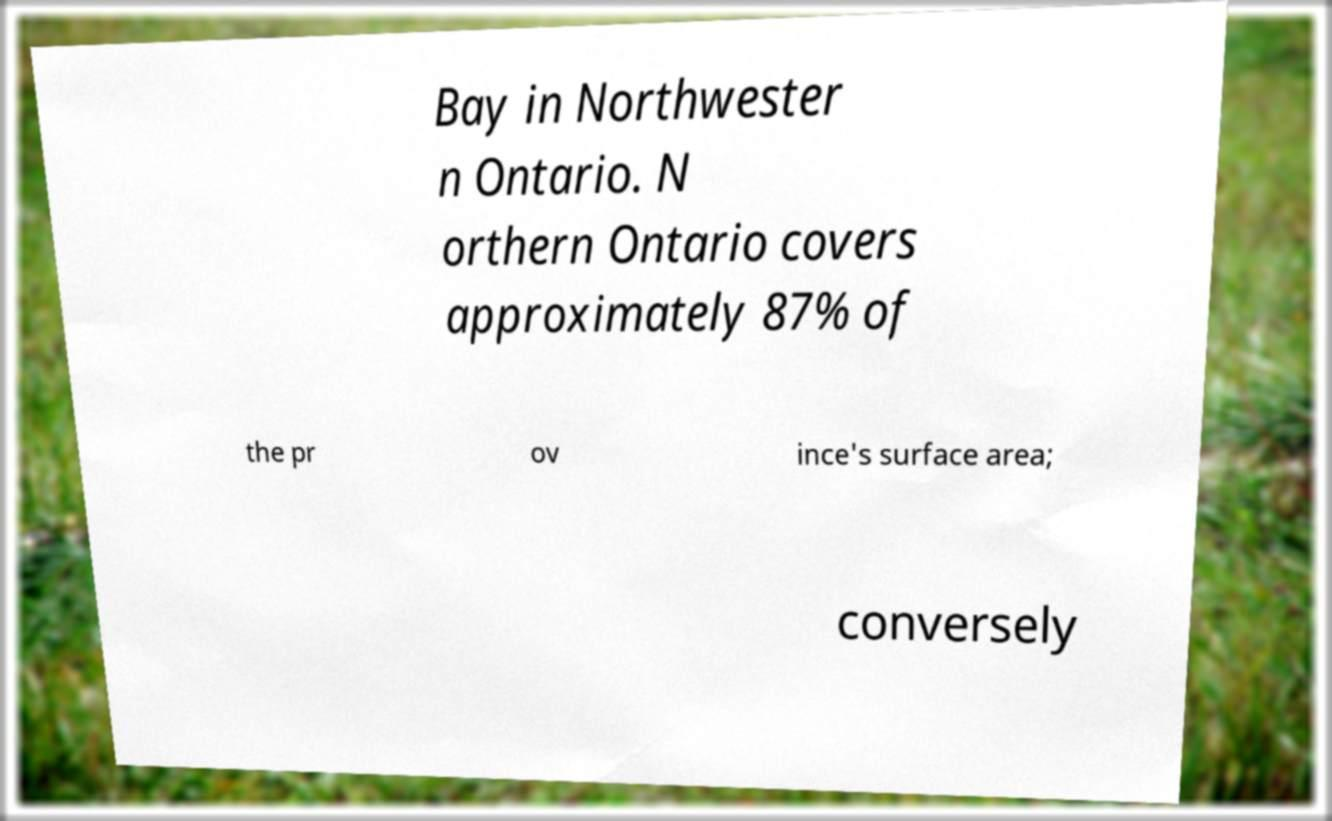Can you read and provide the text displayed in the image?This photo seems to have some interesting text. Can you extract and type it out for me? Bay in Northwester n Ontario. N orthern Ontario covers approximately 87% of the pr ov ince's surface area; conversely 